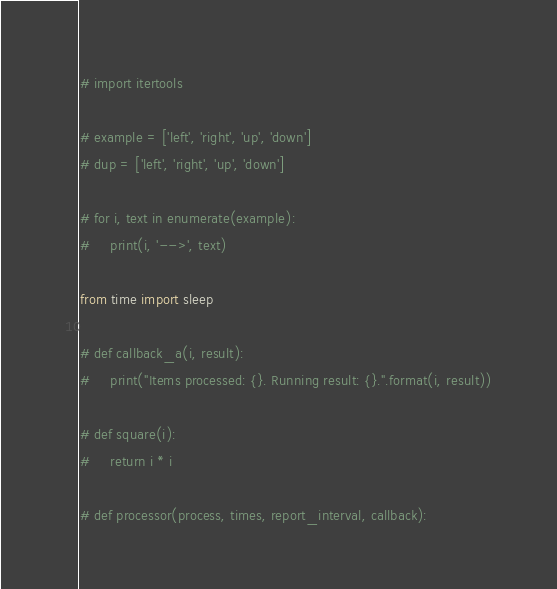<code> <loc_0><loc_0><loc_500><loc_500><_Python_># import itertools

# example = ['left', 'right', 'up', 'down']
# dup = ['left', 'right', 'up', 'down']

# for i, text in enumerate(example):
#     print(i, '-->', text)

from time import sleep

# def callback_a(i, result):
#     print("Items processed: {}. Running result: {}.".format(i, result))

# def square(i):
#     return i * i

# def processor(process, times, report_interval, callback):</code> 